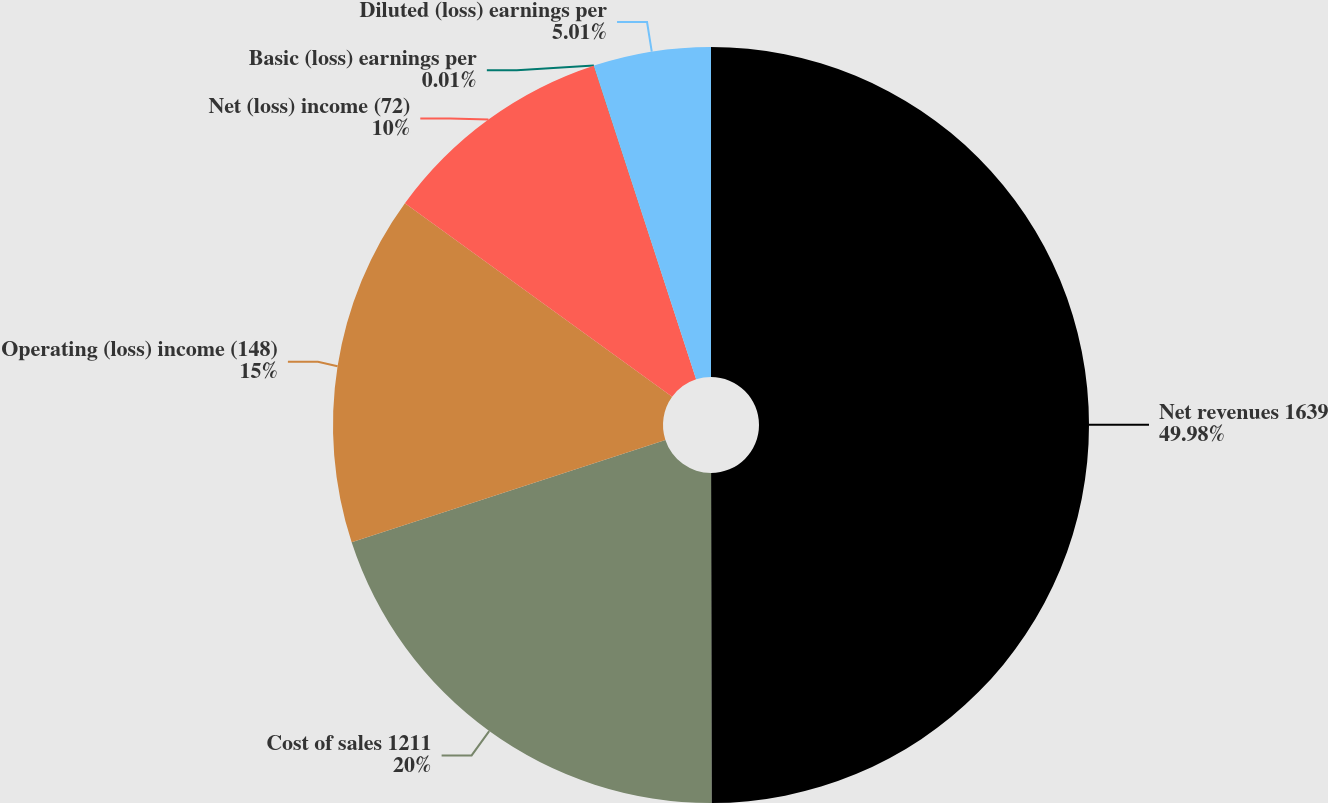Convert chart to OTSL. <chart><loc_0><loc_0><loc_500><loc_500><pie_chart><fcel>Net revenues 1639<fcel>Cost of sales 1211<fcel>Operating (loss) income (148)<fcel>Net (loss) income (72)<fcel>Basic (loss) earnings per<fcel>Diluted (loss) earnings per<nl><fcel>49.98%<fcel>20.0%<fcel>15.0%<fcel>10.0%<fcel>0.01%<fcel>5.01%<nl></chart> 